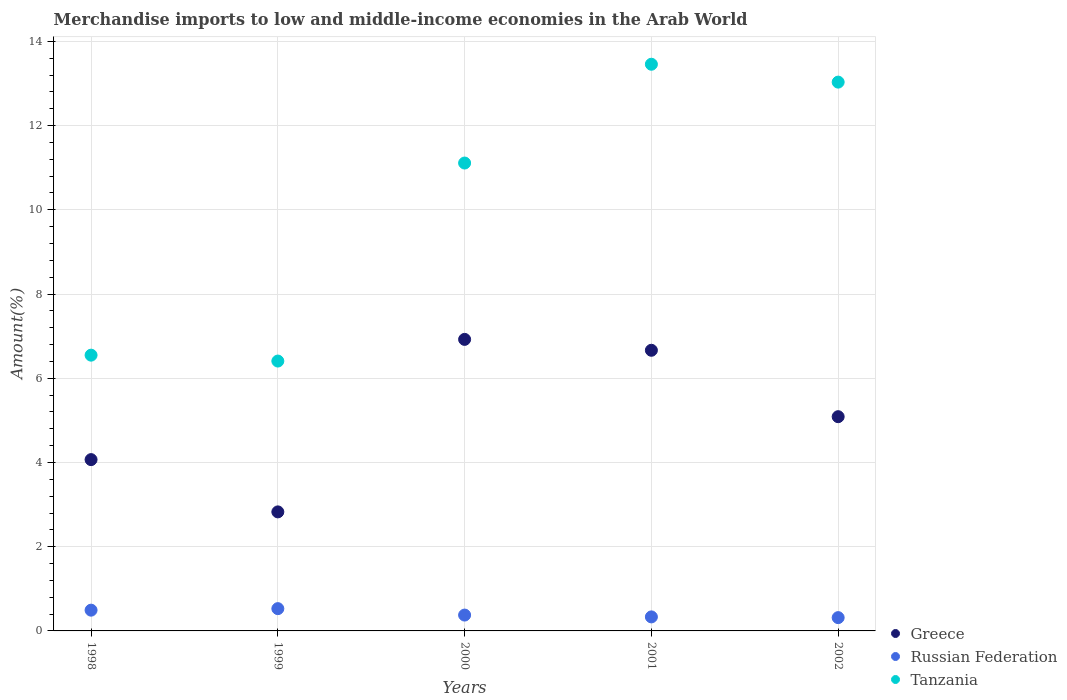What is the percentage of amount earned from merchandise imports in Greece in 2000?
Provide a succinct answer. 6.92. Across all years, what is the maximum percentage of amount earned from merchandise imports in Tanzania?
Keep it short and to the point. 13.46. Across all years, what is the minimum percentage of amount earned from merchandise imports in Russian Federation?
Your answer should be very brief. 0.32. In which year was the percentage of amount earned from merchandise imports in Tanzania maximum?
Provide a succinct answer. 2001. What is the total percentage of amount earned from merchandise imports in Tanzania in the graph?
Your answer should be compact. 50.56. What is the difference between the percentage of amount earned from merchandise imports in Tanzania in 2000 and that in 2001?
Offer a very short reply. -2.35. What is the difference between the percentage of amount earned from merchandise imports in Russian Federation in 1998 and the percentage of amount earned from merchandise imports in Greece in 2002?
Your answer should be compact. -4.59. What is the average percentage of amount earned from merchandise imports in Tanzania per year?
Ensure brevity in your answer.  10.11. In the year 1999, what is the difference between the percentage of amount earned from merchandise imports in Greece and percentage of amount earned from merchandise imports in Russian Federation?
Your answer should be very brief. 2.3. In how many years, is the percentage of amount earned from merchandise imports in Tanzania greater than 8.8 %?
Your response must be concise. 3. What is the ratio of the percentage of amount earned from merchandise imports in Greece in 1998 to that in 1999?
Offer a very short reply. 1.44. Is the percentage of amount earned from merchandise imports in Russian Federation in 1999 less than that in 2002?
Offer a very short reply. No. Is the difference between the percentage of amount earned from merchandise imports in Greece in 2000 and 2002 greater than the difference between the percentage of amount earned from merchandise imports in Russian Federation in 2000 and 2002?
Your response must be concise. Yes. What is the difference between the highest and the second highest percentage of amount earned from merchandise imports in Tanzania?
Give a very brief answer. 0.42. What is the difference between the highest and the lowest percentage of amount earned from merchandise imports in Tanzania?
Offer a very short reply. 7.05. In how many years, is the percentage of amount earned from merchandise imports in Tanzania greater than the average percentage of amount earned from merchandise imports in Tanzania taken over all years?
Provide a short and direct response. 3. Is the sum of the percentage of amount earned from merchandise imports in Greece in 1998 and 2001 greater than the maximum percentage of amount earned from merchandise imports in Russian Federation across all years?
Ensure brevity in your answer.  Yes. Does the percentage of amount earned from merchandise imports in Russian Federation monotonically increase over the years?
Provide a succinct answer. No. Is the percentage of amount earned from merchandise imports in Russian Federation strictly greater than the percentage of amount earned from merchandise imports in Greece over the years?
Ensure brevity in your answer.  No. How many dotlines are there?
Provide a short and direct response. 3. What is the difference between two consecutive major ticks on the Y-axis?
Offer a terse response. 2. Are the values on the major ticks of Y-axis written in scientific E-notation?
Give a very brief answer. No. Does the graph contain any zero values?
Keep it short and to the point. No. Does the graph contain grids?
Provide a short and direct response. Yes. Where does the legend appear in the graph?
Your response must be concise. Bottom right. What is the title of the graph?
Keep it short and to the point. Merchandise imports to low and middle-income economies in the Arab World. What is the label or title of the X-axis?
Give a very brief answer. Years. What is the label or title of the Y-axis?
Your response must be concise. Amount(%). What is the Amount(%) in Greece in 1998?
Give a very brief answer. 4.07. What is the Amount(%) of Russian Federation in 1998?
Make the answer very short. 0.49. What is the Amount(%) of Tanzania in 1998?
Offer a terse response. 6.55. What is the Amount(%) of Greece in 1999?
Provide a succinct answer. 2.83. What is the Amount(%) of Russian Federation in 1999?
Your response must be concise. 0.53. What is the Amount(%) of Tanzania in 1999?
Your answer should be compact. 6.41. What is the Amount(%) of Greece in 2000?
Your response must be concise. 6.92. What is the Amount(%) in Russian Federation in 2000?
Provide a short and direct response. 0.38. What is the Amount(%) of Tanzania in 2000?
Provide a succinct answer. 11.11. What is the Amount(%) in Greece in 2001?
Provide a short and direct response. 6.66. What is the Amount(%) of Russian Federation in 2001?
Your answer should be very brief. 0.33. What is the Amount(%) in Tanzania in 2001?
Offer a terse response. 13.46. What is the Amount(%) of Greece in 2002?
Ensure brevity in your answer.  5.09. What is the Amount(%) in Russian Federation in 2002?
Your answer should be very brief. 0.32. What is the Amount(%) in Tanzania in 2002?
Provide a short and direct response. 13.03. Across all years, what is the maximum Amount(%) in Greece?
Your answer should be very brief. 6.92. Across all years, what is the maximum Amount(%) of Russian Federation?
Make the answer very short. 0.53. Across all years, what is the maximum Amount(%) in Tanzania?
Provide a short and direct response. 13.46. Across all years, what is the minimum Amount(%) of Greece?
Give a very brief answer. 2.83. Across all years, what is the minimum Amount(%) of Russian Federation?
Give a very brief answer. 0.32. Across all years, what is the minimum Amount(%) of Tanzania?
Provide a succinct answer. 6.41. What is the total Amount(%) of Greece in the graph?
Offer a very short reply. 25.57. What is the total Amount(%) of Russian Federation in the graph?
Give a very brief answer. 2.05. What is the total Amount(%) in Tanzania in the graph?
Offer a terse response. 50.56. What is the difference between the Amount(%) of Greece in 1998 and that in 1999?
Give a very brief answer. 1.24. What is the difference between the Amount(%) of Russian Federation in 1998 and that in 1999?
Your response must be concise. -0.04. What is the difference between the Amount(%) in Tanzania in 1998 and that in 1999?
Make the answer very short. 0.14. What is the difference between the Amount(%) in Greece in 1998 and that in 2000?
Ensure brevity in your answer.  -2.86. What is the difference between the Amount(%) in Russian Federation in 1998 and that in 2000?
Ensure brevity in your answer.  0.12. What is the difference between the Amount(%) in Tanzania in 1998 and that in 2000?
Offer a very short reply. -4.56. What is the difference between the Amount(%) in Greece in 1998 and that in 2001?
Offer a very short reply. -2.6. What is the difference between the Amount(%) in Russian Federation in 1998 and that in 2001?
Provide a short and direct response. 0.16. What is the difference between the Amount(%) in Tanzania in 1998 and that in 2001?
Provide a short and direct response. -6.91. What is the difference between the Amount(%) of Greece in 1998 and that in 2002?
Offer a very short reply. -1.02. What is the difference between the Amount(%) in Russian Federation in 1998 and that in 2002?
Ensure brevity in your answer.  0.18. What is the difference between the Amount(%) of Tanzania in 1998 and that in 2002?
Your answer should be very brief. -6.48. What is the difference between the Amount(%) in Greece in 1999 and that in 2000?
Make the answer very short. -4.1. What is the difference between the Amount(%) of Russian Federation in 1999 and that in 2000?
Provide a succinct answer. 0.15. What is the difference between the Amount(%) in Tanzania in 1999 and that in 2000?
Offer a very short reply. -4.7. What is the difference between the Amount(%) in Greece in 1999 and that in 2001?
Offer a terse response. -3.84. What is the difference between the Amount(%) of Russian Federation in 1999 and that in 2001?
Ensure brevity in your answer.  0.2. What is the difference between the Amount(%) of Tanzania in 1999 and that in 2001?
Your answer should be compact. -7.05. What is the difference between the Amount(%) of Greece in 1999 and that in 2002?
Provide a short and direct response. -2.26. What is the difference between the Amount(%) in Russian Federation in 1999 and that in 2002?
Provide a short and direct response. 0.21. What is the difference between the Amount(%) in Tanzania in 1999 and that in 2002?
Your response must be concise. -6.62. What is the difference between the Amount(%) in Greece in 2000 and that in 2001?
Offer a very short reply. 0.26. What is the difference between the Amount(%) in Russian Federation in 2000 and that in 2001?
Provide a succinct answer. 0.04. What is the difference between the Amount(%) of Tanzania in 2000 and that in 2001?
Ensure brevity in your answer.  -2.35. What is the difference between the Amount(%) in Greece in 2000 and that in 2002?
Make the answer very short. 1.84. What is the difference between the Amount(%) of Russian Federation in 2000 and that in 2002?
Offer a terse response. 0.06. What is the difference between the Amount(%) in Tanzania in 2000 and that in 2002?
Your response must be concise. -1.92. What is the difference between the Amount(%) in Greece in 2001 and that in 2002?
Your answer should be compact. 1.58. What is the difference between the Amount(%) in Russian Federation in 2001 and that in 2002?
Provide a succinct answer. 0.02. What is the difference between the Amount(%) of Tanzania in 2001 and that in 2002?
Make the answer very short. 0.42. What is the difference between the Amount(%) in Greece in 1998 and the Amount(%) in Russian Federation in 1999?
Provide a short and direct response. 3.54. What is the difference between the Amount(%) of Greece in 1998 and the Amount(%) of Tanzania in 1999?
Offer a terse response. -2.34. What is the difference between the Amount(%) of Russian Federation in 1998 and the Amount(%) of Tanzania in 1999?
Ensure brevity in your answer.  -5.92. What is the difference between the Amount(%) of Greece in 1998 and the Amount(%) of Russian Federation in 2000?
Your answer should be very brief. 3.69. What is the difference between the Amount(%) of Greece in 1998 and the Amount(%) of Tanzania in 2000?
Your answer should be very brief. -7.04. What is the difference between the Amount(%) in Russian Federation in 1998 and the Amount(%) in Tanzania in 2000?
Offer a terse response. -10.62. What is the difference between the Amount(%) in Greece in 1998 and the Amount(%) in Russian Federation in 2001?
Keep it short and to the point. 3.73. What is the difference between the Amount(%) in Greece in 1998 and the Amount(%) in Tanzania in 2001?
Your answer should be compact. -9.39. What is the difference between the Amount(%) of Russian Federation in 1998 and the Amount(%) of Tanzania in 2001?
Your answer should be compact. -12.96. What is the difference between the Amount(%) of Greece in 1998 and the Amount(%) of Russian Federation in 2002?
Offer a very short reply. 3.75. What is the difference between the Amount(%) in Greece in 1998 and the Amount(%) in Tanzania in 2002?
Your answer should be very brief. -8.96. What is the difference between the Amount(%) in Russian Federation in 1998 and the Amount(%) in Tanzania in 2002?
Provide a short and direct response. -12.54. What is the difference between the Amount(%) of Greece in 1999 and the Amount(%) of Russian Federation in 2000?
Provide a short and direct response. 2.45. What is the difference between the Amount(%) of Greece in 1999 and the Amount(%) of Tanzania in 2000?
Offer a very short reply. -8.28. What is the difference between the Amount(%) in Russian Federation in 1999 and the Amount(%) in Tanzania in 2000?
Provide a short and direct response. -10.58. What is the difference between the Amount(%) of Greece in 1999 and the Amount(%) of Russian Federation in 2001?
Ensure brevity in your answer.  2.49. What is the difference between the Amount(%) in Greece in 1999 and the Amount(%) in Tanzania in 2001?
Make the answer very short. -10.63. What is the difference between the Amount(%) in Russian Federation in 1999 and the Amount(%) in Tanzania in 2001?
Your answer should be compact. -12.93. What is the difference between the Amount(%) in Greece in 1999 and the Amount(%) in Russian Federation in 2002?
Offer a terse response. 2.51. What is the difference between the Amount(%) in Greece in 1999 and the Amount(%) in Tanzania in 2002?
Offer a very short reply. -10.21. What is the difference between the Amount(%) of Russian Federation in 1999 and the Amount(%) of Tanzania in 2002?
Provide a short and direct response. -12.5. What is the difference between the Amount(%) of Greece in 2000 and the Amount(%) of Russian Federation in 2001?
Offer a terse response. 6.59. What is the difference between the Amount(%) of Greece in 2000 and the Amount(%) of Tanzania in 2001?
Ensure brevity in your answer.  -6.53. What is the difference between the Amount(%) of Russian Federation in 2000 and the Amount(%) of Tanzania in 2001?
Keep it short and to the point. -13.08. What is the difference between the Amount(%) in Greece in 2000 and the Amount(%) in Russian Federation in 2002?
Keep it short and to the point. 6.61. What is the difference between the Amount(%) of Greece in 2000 and the Amount(%) of Tanzania in 2002?
Provide a short and direct response. -6.11. What is the difference between the Amount(%) of Russian Federation in 2000 and the Amount(%) of Tanzania in 2002?
Keep it short and to the point. -12.66. What is the difference between the Amount(%) in Greece in 2001 and the Amount(%) in Russian Federation in 2002?
Offer a very short reply. 6.35. What is the difference between the Amount(%) of Greece in 2001 and the Amount(%) of Tanzania in 2002?
Provide a short and direct response. -6.37. What is the difference between the Amount(%) in Russian Federation in 2001 and the Amount(%) in Tanzania in 2002?
Make the answer very short. -12.7. What is the average Amount(%) of Greece per year?
Give a very brief answer. 5.11. What is the average Amount(%) in Russian Federation per year?
Ensure brevity in your answer.  0.41. What is the average Amount(%) in Tanzania per year?
Your response must be concise. 10.11. In the year 1998, what is the difference between the Amount(%) of Greece and Amount(%) of Russian Federation?
Keep it short and to the point. 3.57. In the year 1998, what is the difference between the Amount(%) in Greece and Amount(%) in Tanzania?
Keep it short and to the point. -2.48. In the year 1998, what is the difference between the Amount(%) in Russian Federation and Amount(%) in Tanzania?
Your answer should be compact. -6.06. In the year 1999, what is the difference between the Amount(%) of Greece and Amount(%) of Russian Federation?
Provide a succinct answer. 2.3. In the year 1999, what is the difference between the Amount(%) in Greece and Amount(%) in Tanzania?
Offer a terse response. -3.58. In the year 1999, what is the difference between the Amount(%) of Russian Federation and Amount(%) of Tanzania?
Your answer should be compact. -5.88. In the year 2000, what is the difference between the Amount(%) of Greece and Amount(%) of Russian Federation?
Keep it short and to the point. 6.55. In the year 2000, what is the difference between the Amount(%) of Greece and Amount(%) of Tanzania?
Make the answer very short. -4.19. In the year 2000, what is the difference between the Amount(%) of Russian Federation and Amount(%) of Tanzania?
Make the answer very short. -10.73. In the year 2001, what is the difference between the Amount(%) of Greece and Amount(%) of Russian Federation?
Keep it short and to the point. 6.33. In the year 2001, what is the difference between the Amount(%) of Greece and Amount(%) of Tanzania?
Offer a very short reply. -6.79. In the year 2001, what is the difference between the Amount(%) of Russian Federation and Amount(%) of Tanzania?
Offer a terse response. -13.12. In the year 2002, what is the difference between the Amount(%) of Greece and Amount(%) of Russian Federation?
Provide a succinct answer. 4.77. In the year 2002, what is the difference between the Amount(%) in Greece and Amount(%) in Tanzania?
Your answer should be very brief. -7.94. In the year 2002, what is the difference between the Amount(%) in Russian Federation and Amount(%) in Tanzania?
Provide a short and direct response. -12.72. What is the ratio of the Amount(%) in Greece in 1998 to that in 1999?
Offer a terse response. 1.44. What is the ratio of the Amount(%) of Russian Federation in 1998 to that in 1999?
Provide a succinct answer. 0.93. What is the ratio of the Amount(%) in Tanzania in 1998 to that in 1999?
Your response must be concise. 1.02. What is the ratio of the Amount(%) in Greece in 1998 to that in 2000?
Ensure brevity in your answer.  0.59. What is the ratio of the Amount(%) in Russian Federation in 1998 to that in 2000?
Give a very brief answer. 1.31. What is the ratio of the Amount(%) of Tanzania in 1998 to that in 2000?
Provide a short and direct response. 0.59. What is the ratio of the Amount(%) in Greece in 1998 to that in 2001?
Provide a short and direct response. 0.61. What is the ratio of the Amount(%) in Russian Federation in 1998 to that in 2001?
Your answer should be compact. 1.48. What is the ratio of the Amount(%) in Tanzania in 1998 to that in 2001?
Ensure brevity in your answer.  0.49. What is the ratio of the Amount(%) in Greece in 1998 to that in 2002?
Ensure brevity in your answer.  0.8. What is the ratio of the Amount(%) of Russian Federation in 1998 to that in 2002?
Your response must be concise. 1.56. What is the ratio of the Amount(%) of Tanzania in 1998 to that in 2002?
Provide a succinct answer. 0.5. What is the ratio of the Amount(%) of Greece in 1999 to that in 2000?
Your answer should be very brief. 0.41. What is the ratio of the Amount(%) in Russian Federation in 1999 to that in 2000?
Ensure brevity in your answer.  1.41. What is the ratio of the Amount(%) of Tanzania in 1999 to that in 2000?
Your answer should be compact. 0.58. What is the ratio of the Amount(%) in Greece in 1999 to that in 2001?
Keep it short and to the point. 0.42. What is the ratio of the Amount(%) in Russian Federation in 1999 to that in 2001?
Keep it short and to the point. 1.59. What is the ratio of the Amount(%) of Tanzania in 1999 to that in 2001?
Provide a short and direct response. 0.48. What is the ratio of the Amount(%) of Greece in 1999 to that in 2002?
Make the answer very short. 0.56. What is the ratio of the Amount(%) of Russian Federation in 1999 to that in 2002?
Offer a very short reply. 1.68. What is the ratio of the Amount(%) in Tanzania in 1999 to that in 2002?
Your response must be concise. 0.49. What is the ratio of the Amount(%) of Greece in 2000 to that in 2001?
Your answer should be compact. 1.04. What is the ratio of the Amount(%) in Russian Federation in 2000 to that in 2001?
Make the answer very short. 1.13. What is the ratio of the Amount(%) of Tanzania in 2000 to that in 2001?
Offer a terse response. 0.83. What is the ratio of the Amount(%) of Greece in 2000 to that in 2002?
Make the answer very short. 1.36. What is the ratio of the Amount(%) of Russian Federation in 2000 to that in 2002?
Keep it short and to the point. 1.19. What is the ratio of the Amount(%) of Tanzania in 2000 to that in 2002?
Your response must be concise. 0.85. What is the ratio of the Amount(%) of Greece in 2001 to that in 2002?
Provide a succinct answer. 1.31. What is the ratio of the Amount(%) in Russian Federation in 2001 to that in 2002?
Offer a very short reply. 1.05. What is the ratio of the Amount(%) of Tanzania in 2001 to that in 2002?
Your answer should be very brief. 1.03. What is the difference between the highest and the second highest Amount(%) of Greece?
Offer a terse response. 0.26. What is the difference between the highest and the second highest Amount(%) of Russian Federation?
Make the answer very short. 0.04. What is the difference between the highest and the second highest Amount(%) of Tanzania?
Your response must be concise. 0.42. What is the difference between the highest and the lowest Amount(%) of Greece?
Give a very brief answer. 4.1. What is the difference between the highest and the lowest Amount(%) in Russian Federation?
Offer a very short reply. 0.21. What is the difference between the highest and the lowest Amount(%) in Tanzania?
Keep it short and to the point. 7.05. 